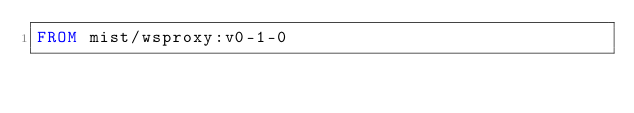<code> <loc_0><loc_0><loc_500><loc_500><_Dockerfile_>FROM mist/wsproxy:v0-1-0
</code> 